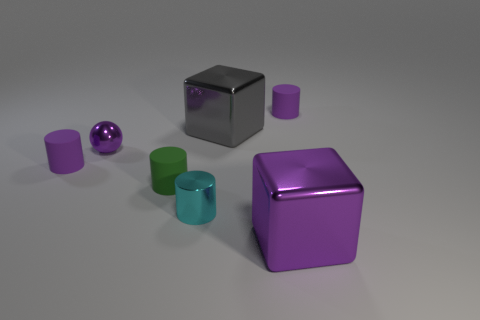What shape is the gray object that is the same material as the small sphere?
Provide a short and direct response. Cube. There is a gray object right of the cyan metal object; what number of small cyan things are in front of it?
Your response must be concise. 1. How many cubes are both behind the small green thing and in front of the small metal ball?
Your answer should be very brief. 0. How many other objects are there of the same material as the small purple sphere?
Provide a short and direct response. 3. There is a cylinder right of the large object that is in front of the shiny sphere; what is its color?
Ensure brevity in your answer.  Purple. Is the color of the cube that is in front of the green matte object the same as the small ball?
Offer a very short reply. Yes. Do the green cylinder and the gray object have the same size?
Your response must be concise. No. The purple metal thing that is the same size as the cyan object is what shape?
Provide a short and direct response. Sphere. Is the size of the purple cylinder to the left of the cyan metallic cylinder the same as the tiny cyan shiny cylinder?
Offer a terse response. Yes. What is the material of the gray thing that is the same size as the purple block?
Offer a very short reply. Metal. 